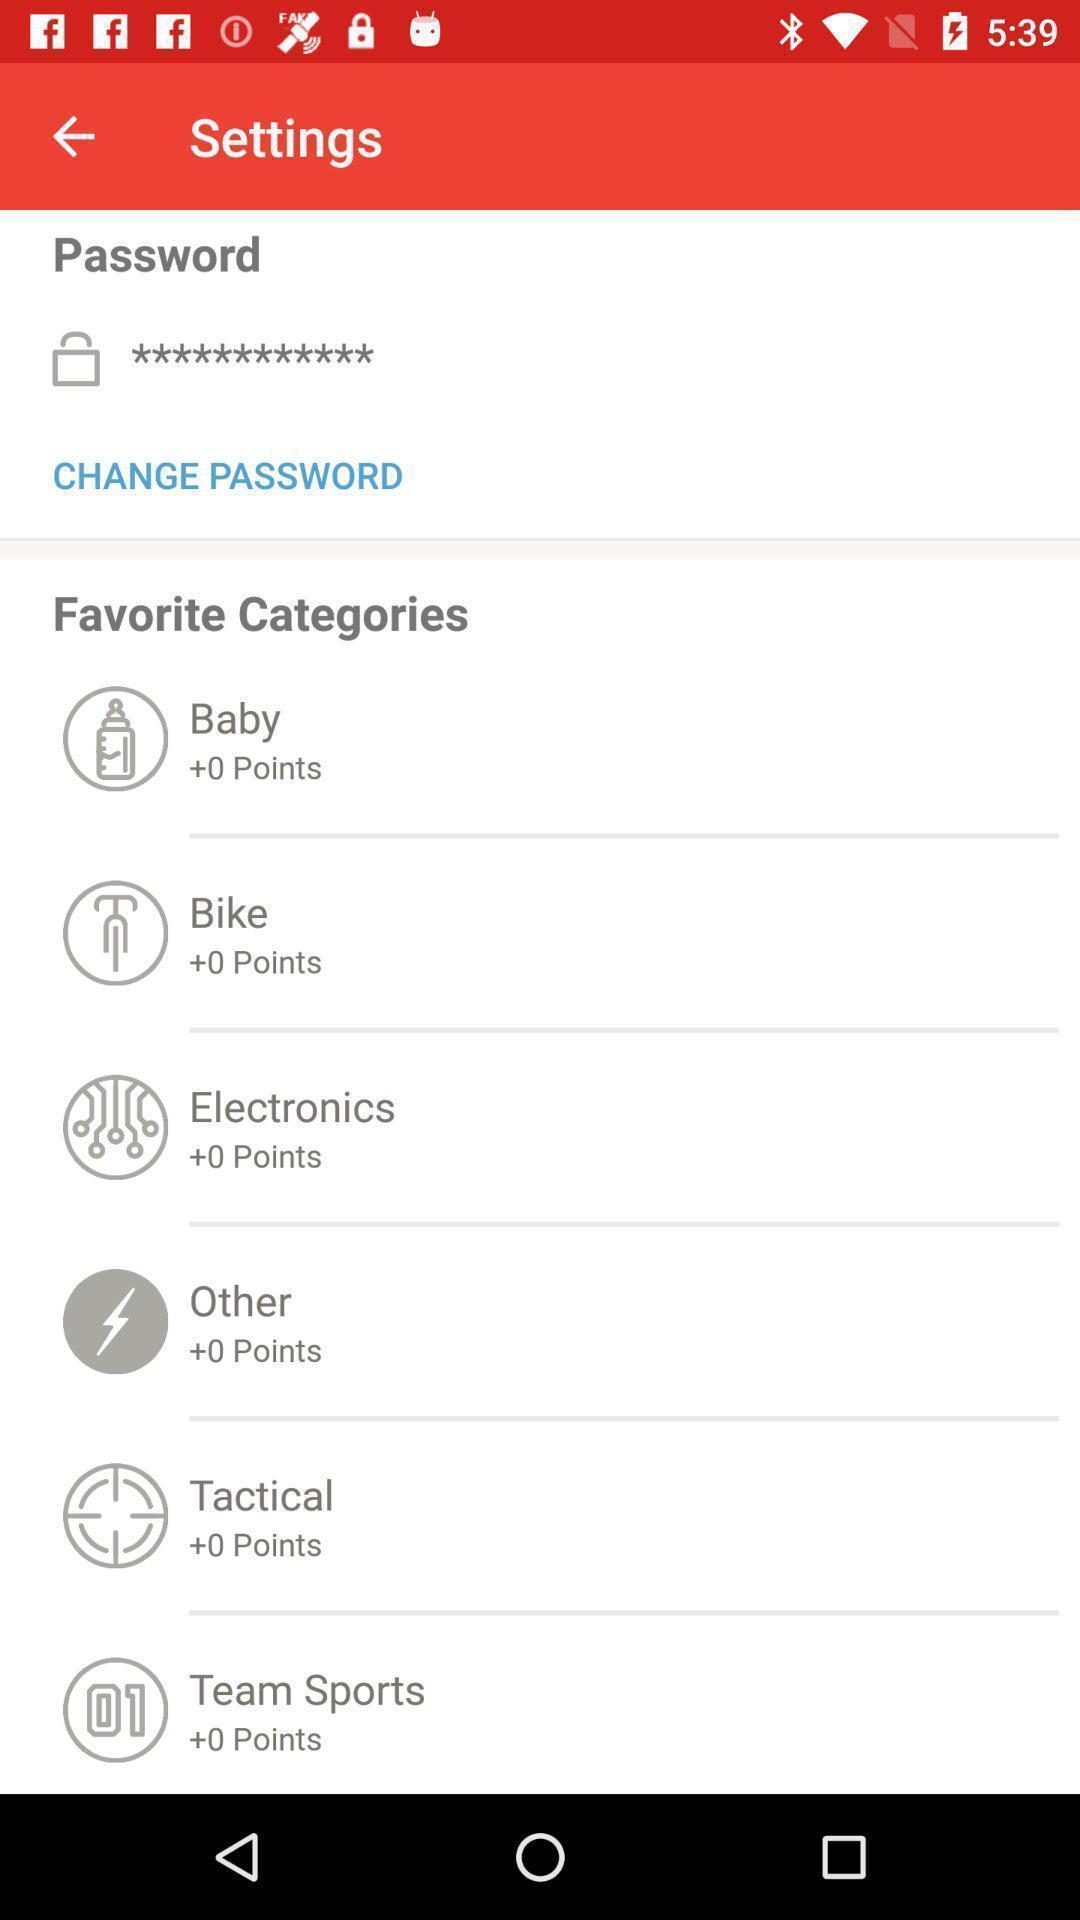Describe the content in this image. Settings page with many options. 